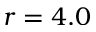Convert formula to latex. <formula><loc_0><loc_0><loc_500><loc_500>r = 4 . 0</formula> 